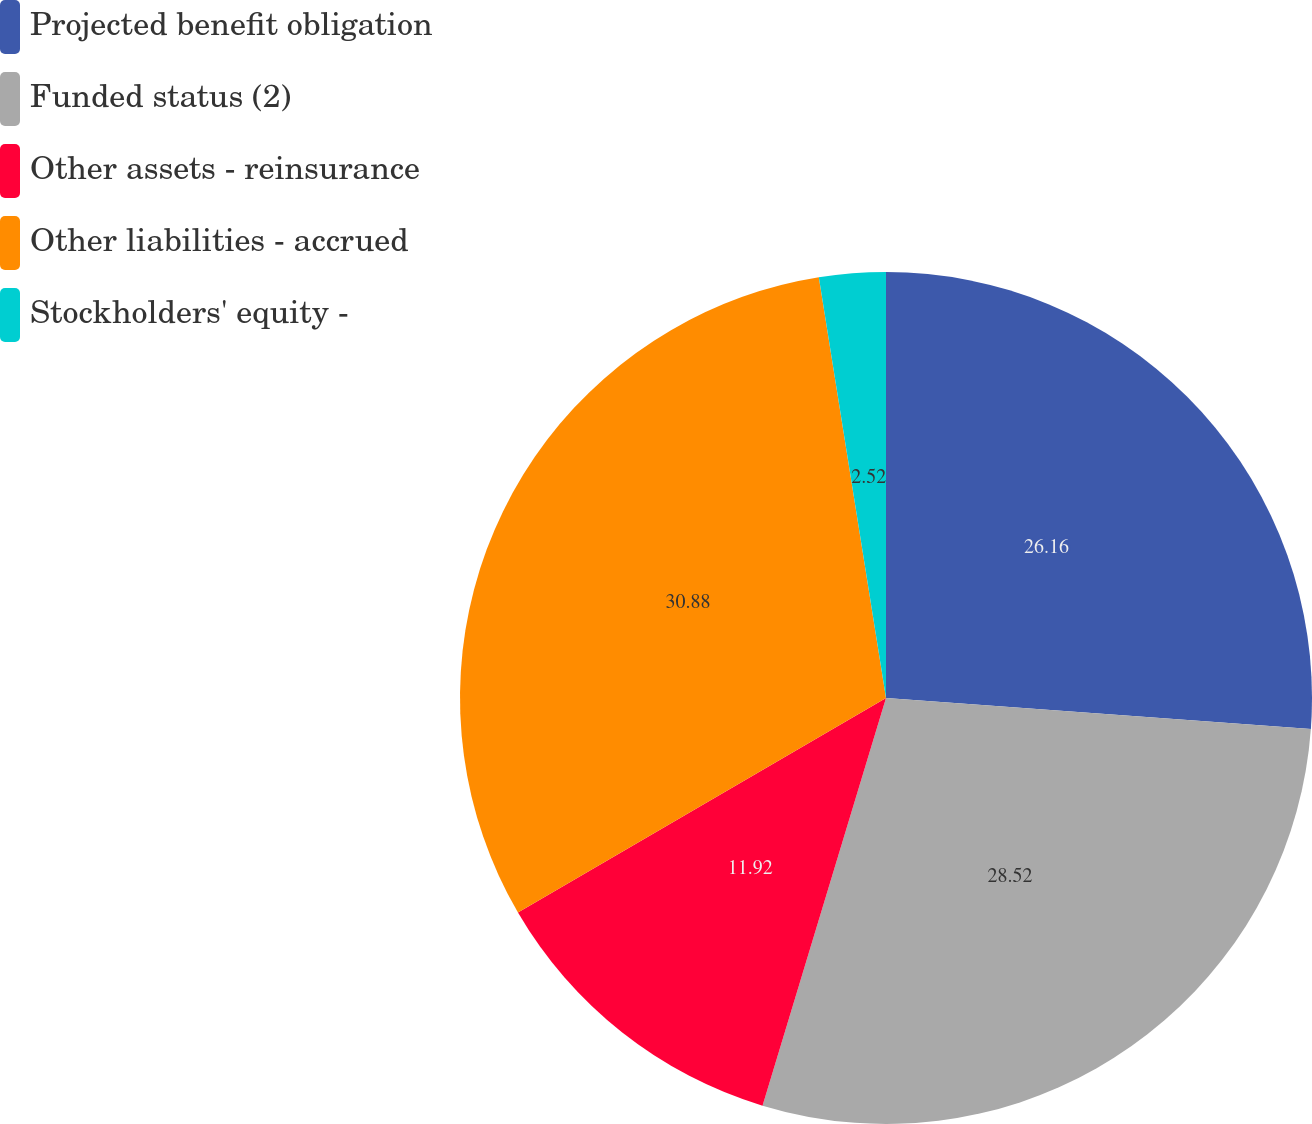<chart> <loc_0><loc_0><loc_500><loc_500><pie_chart><fcel>Projected benefit obligation<fcel>Funded status (2)<fcel>Other assets - reinsurance<fcel>Other liabilities - accrued<fcel>Stockholders' equity -<nl><fcel>26.16%<fcel>28.52%<fcel>11.92%<fcel>30.88%<fcel>2.52%<nl></chart> 